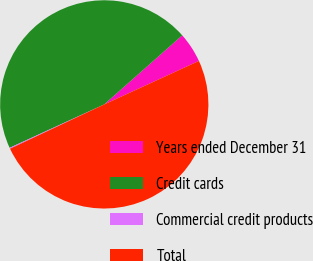Convert chart to OTSL. <chart><loc_0><loc_0><loc_500><loc_500><pie_chart><fcel>Years ended December 31<fcel>Credit cards<fcel>Commercial credit products<fcel>Total<nl><fcel>4.68%<fcel>45.32%<fcel>0.15%<fcel>49.85%<nl></chart> 